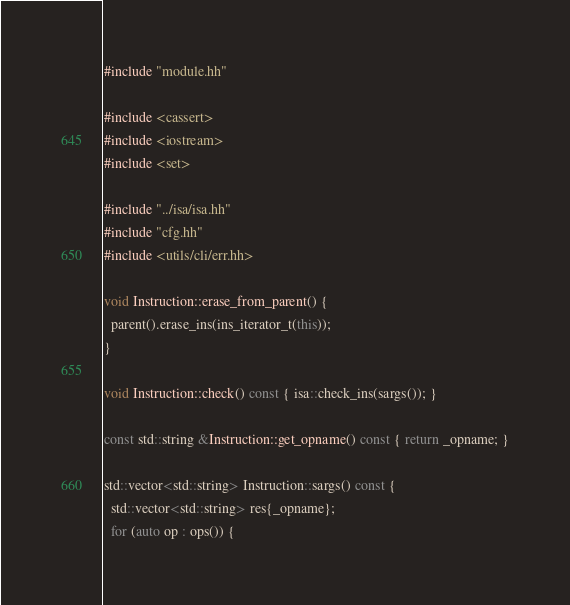<code> <loc_0><loc_0><loc_500><loc_500><_C++_>#include "module.hh"

#include <cassert>
#include <iostream>
#include <set>

#include "../isa/isa.hh"
#include "cfg.hh"
#include <utils/cli/err.hh>

void Instruction::erase_from_parent() {
  parent().erase_ins(ins_iterator_t(this));
}

void Instruction::check() const { isa::check_ins(sargs()); }

const std::string &Instruction::get_opname() const { return _opname; }

std::vector<std::string> Instruction::sargs() const {
  std::vector<std::string> res{_opname};
  for (auto op : ops()) {</code> 